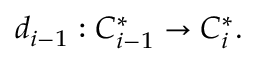<formula> <loc_0><loc_0><loc_500><loc_500>d _ { i - 1 } \colon C _ { i - 1 } ^ { * } \to C _ { i } ^ { * } .</formula> 